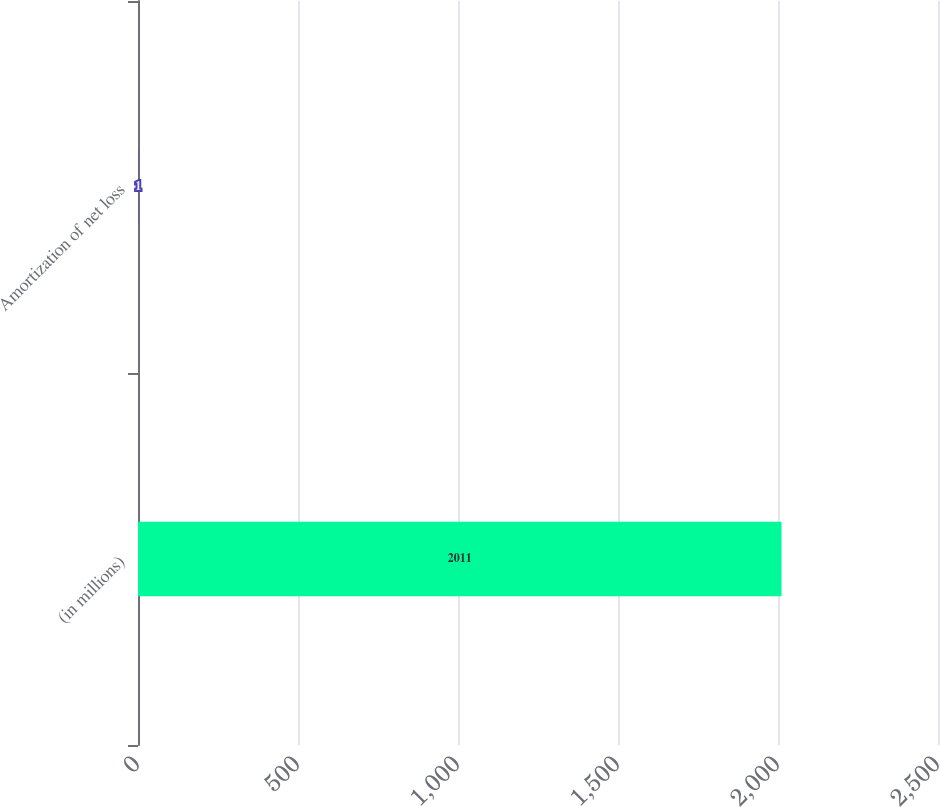<chart> <loc_0><loc_0><loc_500><loc_500><bar_chart><fcel>(in millions)<fcel>Amortization of net loss<nl><fcel>2011<fcel>1<nl></chart> 